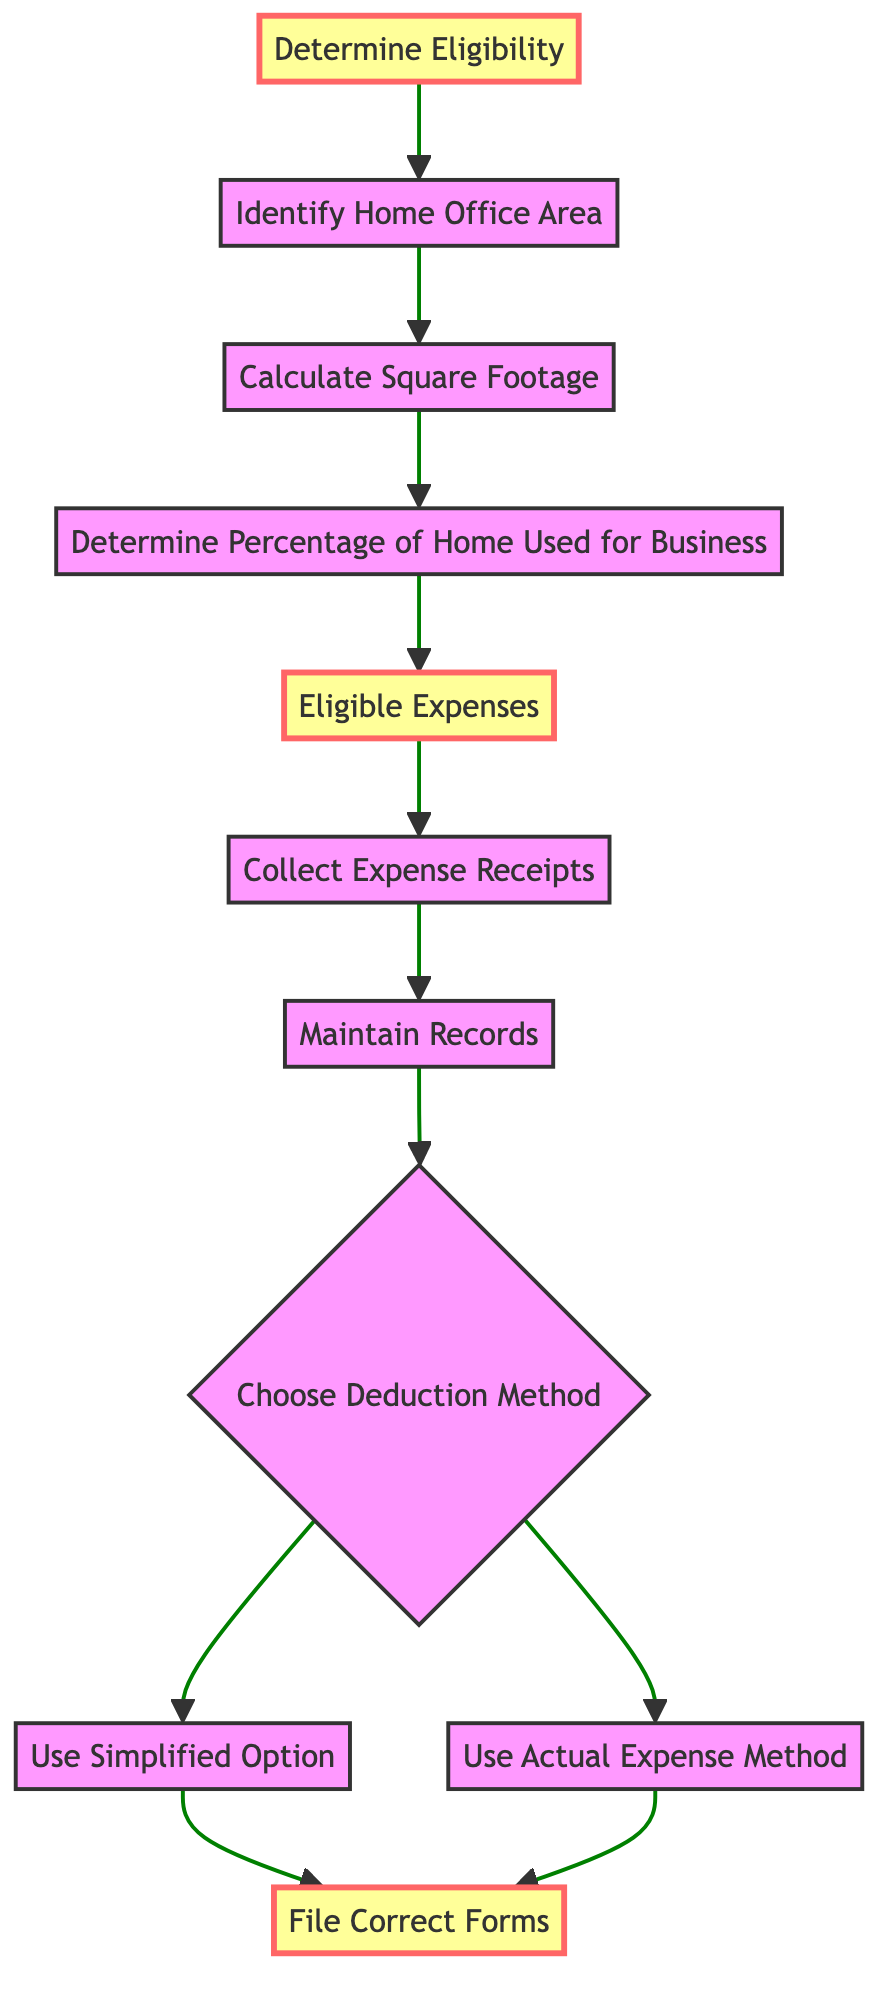What is the first step in maximizing tax deductions for home office expenses? The first node in the diagram is "Determine Eligibility," indicating that this is the initial step that needs to be taken.
Answer: Determine Eligibility How many nodes are present in the diagram? By counting all the distinct steps represented in the diagram, we find a total of eleven nodes.
Answer: Eleven What action must be taken after collecting expense receipts? Following "Collect Expense Receipts," the next step is "Maintain Records," which involves keeping track of all expenses documented.
Answer: Maintain Records Which deduction method options are available after choosing a method? The diagram shows two options that can be chosen after "Choose Deduction Method," which are "Use Simplified Option" and "Use Actual Expense Method."
Answer: Two What is the final action that must be taken to maximize tax deductions? The last step, represented by the node "File Correct Forms," indicates that filing the appropriate forms is necessary to complete the process.
Answer: File Correct Forms If you choose the Simplified Option, which step do you proceed to next? After selecting the "Use Simplified Option," the next action to be taken is to "File Correct Forms," as indicated by the directed edge in the flow of the diagram.
Answer: File Correct Forms True or False: The node "Determine Percentage of Home Used for Business" directly precedes "Eligible Expenses." From the diagram, the edge shows a directed flow from "Determine Percentage of Home Used for Business" to "Eligible Expenses." Therefore, the statement is true.
Answer: True What comes after determining the home office area? Following "Identify Home Office Area," the next step is to "Calculate Square Footage," which is a necessary action.
Answer: Calculate Square Footage 